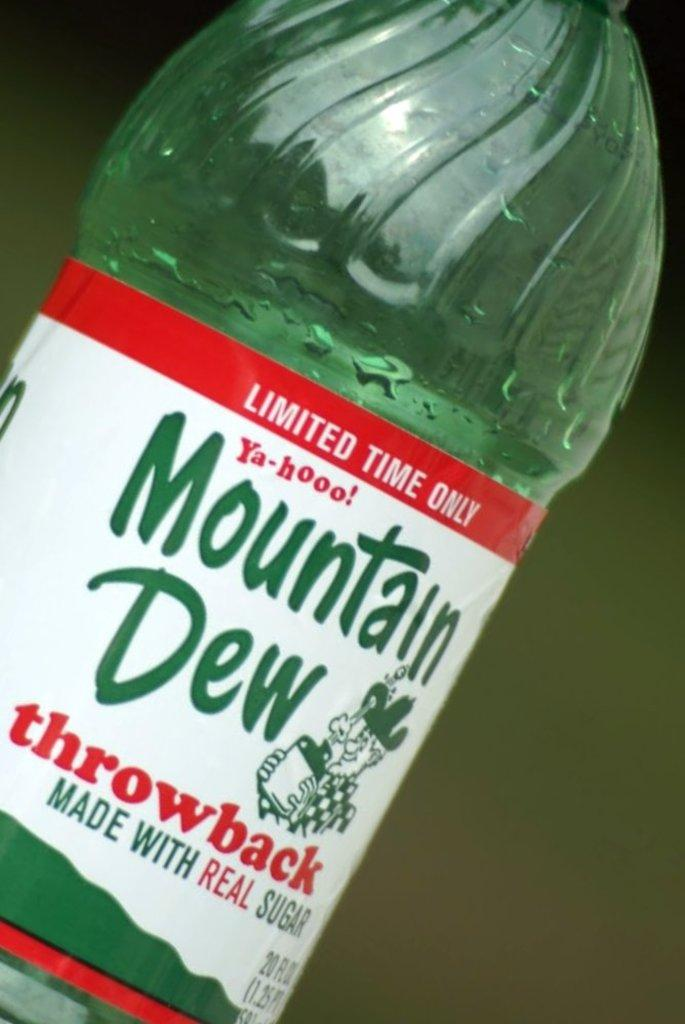What is the color of the juice bottle in the image? The juice bottle in the image is green. What type of rake is being used in the protest for money in the image? There is no rake, protest, or money present in the image; it only features a green juice bottle. 